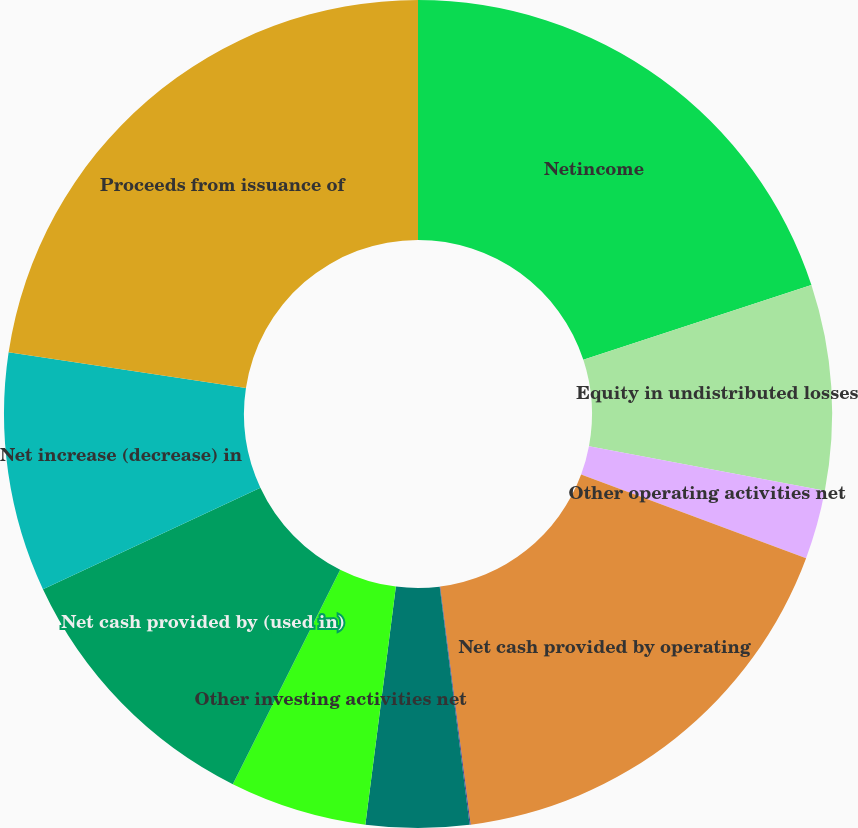Convert chart. <chart><loc_0><loc_0><loc_500><loc_500><pie_chart><fcel>Netincome<fcel>Equity in undistributed losses<fcel>Other operating activities net<fcel>Net cash provided by operating<fcel>Net (purchases) sales of<fcel>Net payments from (to)<fcel>Other investing activities net<fcel>Net cash provided by (used in)<fcel>Net increase (decrease) in<fcel>Proceeds from issuance of<nl><fcel>19.96%<fcel>8.01%<fcel>2.69%<fcel>17.31%<fcel>0.04%<fcel>4.02%<fcel>5.35%<fcel>10.66%<fcel>9.34%<fcel>22.62%<nl></chart> 